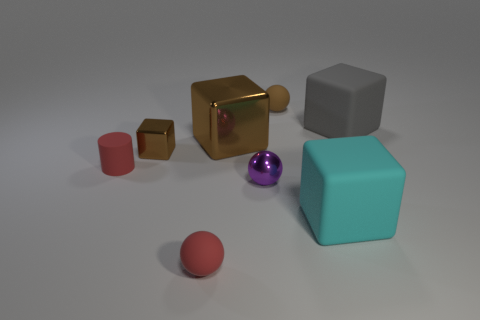Add 2 big cyan matte cubes. How many objects exist? 10 Subtract all big metal blocks. How many blocks are left? 3 Subtract all purple cylinders. How many brown blocks are left? 2 Subtract 1 blocks. How many blocks are left? 3 Subtract all spheres. How many objects are left? 5 Subtract all purple balls. How many balls are left? 2 Add 3 large green matte objects. How many large green matte objects exist? 3 Subtract 0 purple blocks. How many objects are left? 8 Subtract all purple cubes. Subtract all blue cylinders. How many cubes are left? 4 Subtract all small objects. Subtract all large gray blocks. How many objects are left? 2 